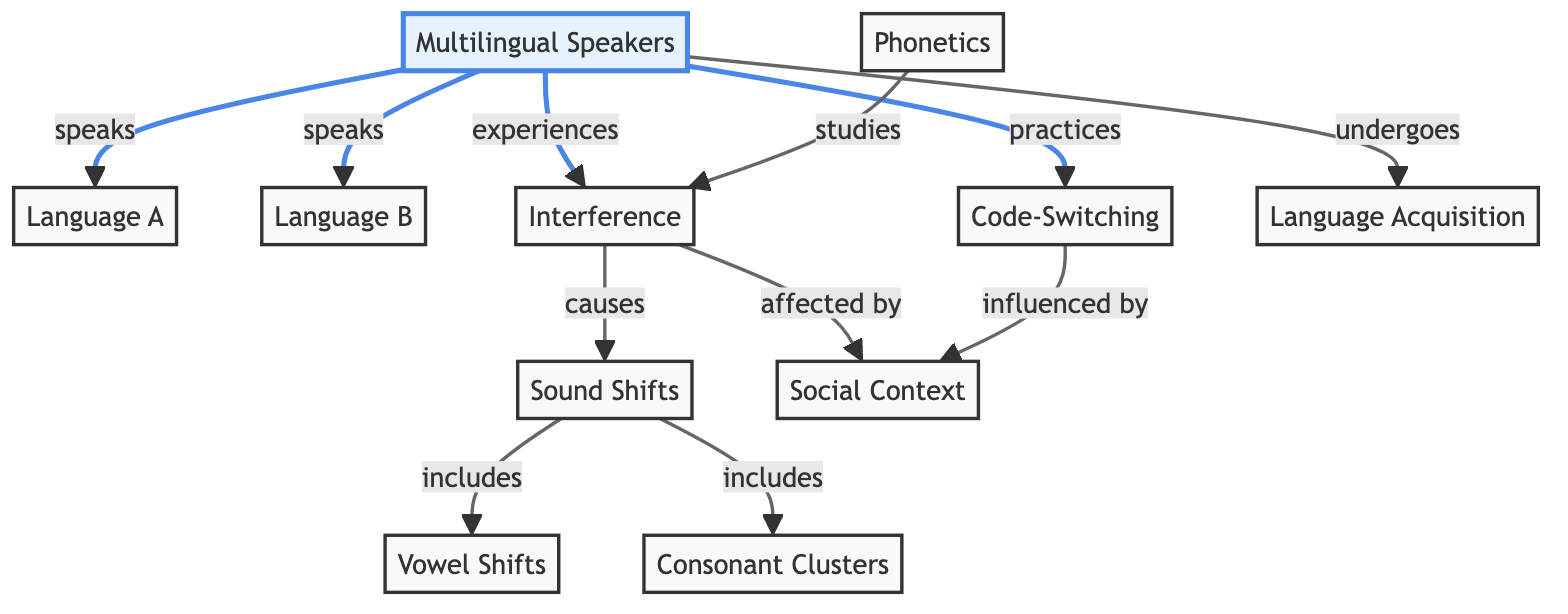What is the number of nodes in the diagram? The diagram lists a total of 11 unique nodes, which include concepts such as Multilingual Speakers, Phonetics, and various linguistic influences.
Answer: 11 Which language does the individual primarily speak? The connection from the node "Multilingual Speakers" to "Language A" indicates that Language A is the primary language spoken by these individuals.
Answer: Language A What does "Interference" cause in the diagram? The edge leading from "Interference" to "Sound Shifts" shows that interference has a direct role in causing sound shifts in speech patterns.
Answer: Sound Shifts How do multilingual speakers experiment with languages? The edge from "Multilingual Speakers" to "Code-Switching" demonstrates that these speakers practice code-switching, indicating the alternation between different languages.
Answer: Code-Switching What is included in "Sound Shifts"? There are two edges emanating from "Sound Shifts" leading to "Vowel Shifts" and "Consonant Clusters," which shows that both types of shifts are included under this category.
Answer: Vowel Shifts and Consonant Clusters What is affected by social context according to the diagram? The edge from "Interference" to "Social Context" implies that interference is influenced or modified by the social environment where the languages are used.
Answer: Interference What do multilingual speakers undergo? The edge from "Multilingual Speakers" to "Language Acquisition" indicates that these individuals undergo the process of acquiring new languages, reflecting their learning experience.
Answer: Language Acquisition How many edges connect "Interference" to other nodes? Examining the connections, there are three outgoing edges from the "Interference" node, leading to "Sound Shifts," "Social Context," and affecting language use.
Answer: 3 Which linguistic area studies the effects of languages on pronunciation? The connection from the node "Phonetics" to "Interference" indicates that phonetics studies how interference manifests in pronunciation and speech sound changes.
Answer: Interference 